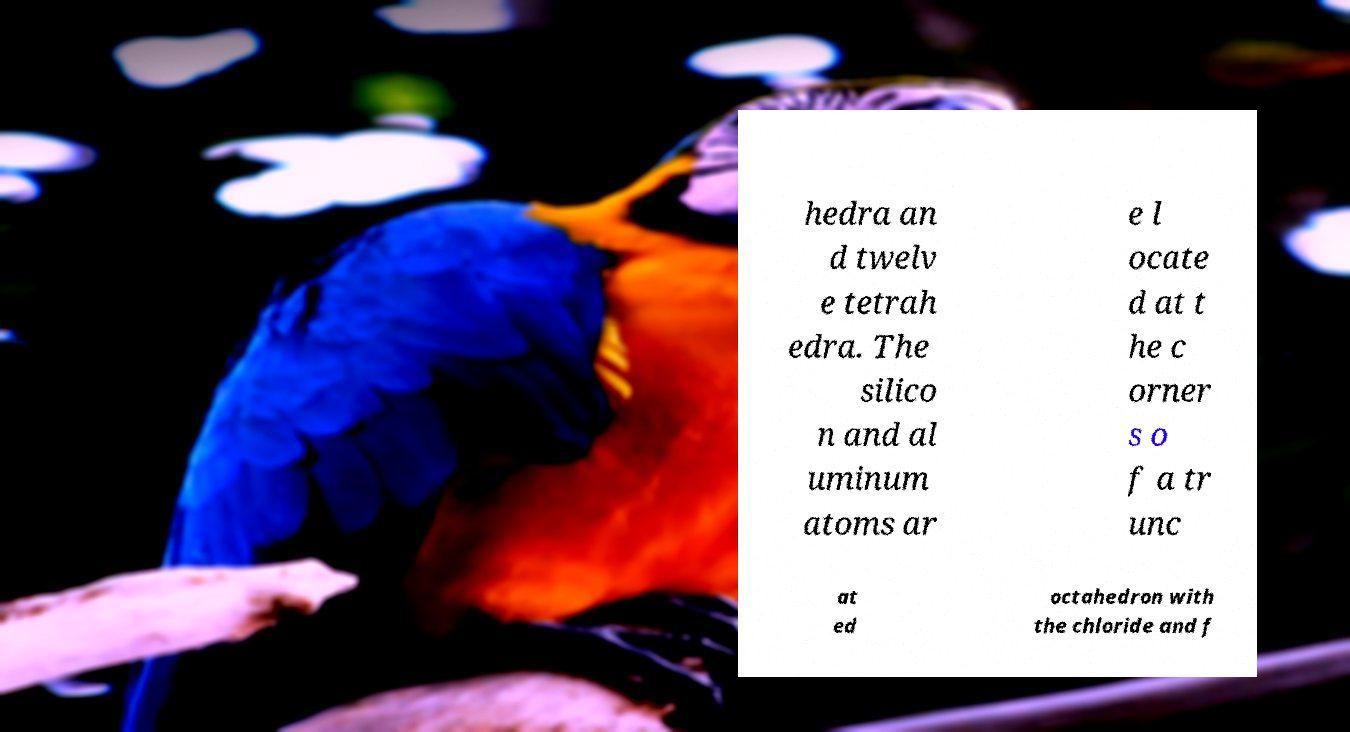For documentation purposes, I need the text within this image transcribed. Could you provide that? hedra an d twelv e tetrah edra. The silico n and al uminum atoms ar e l ocate d at t he c orner s o f a tr unc at ed octahedron with the chloride and f 